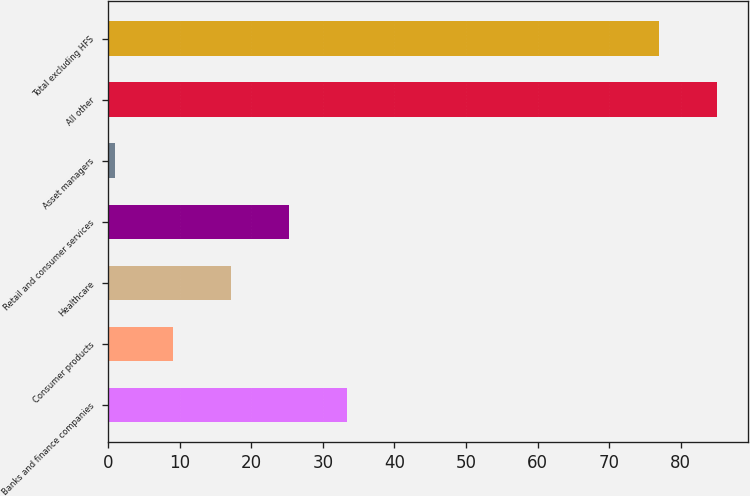Convert chart to OTSL. <chart><loc_0><loc_0><loc_500><loc_500><bar_chart><fcel>Banks and finance companies<fcel>Consumer products<fcel>Healthcare<fcel>Retail and consumer services<fcel>Asset managers<fcel>All other<fcel>Total excluding HFS<nl><fcel>33.4<fcel>9.1<fcel>17.2<fcel>25.3<fcel>1<fcel>85.1<fcel>77<nl></chart> 